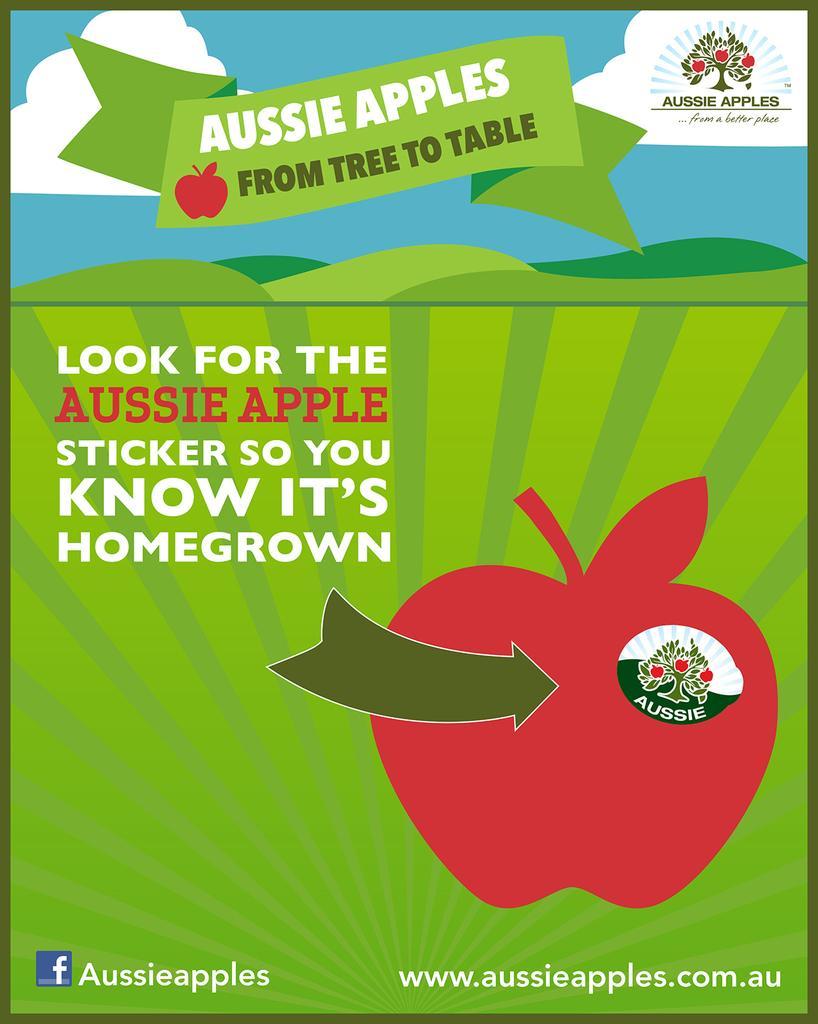Describe this image in one or two sentences. In this picture we can see a poster, here we can see some symbols and some text on it. 